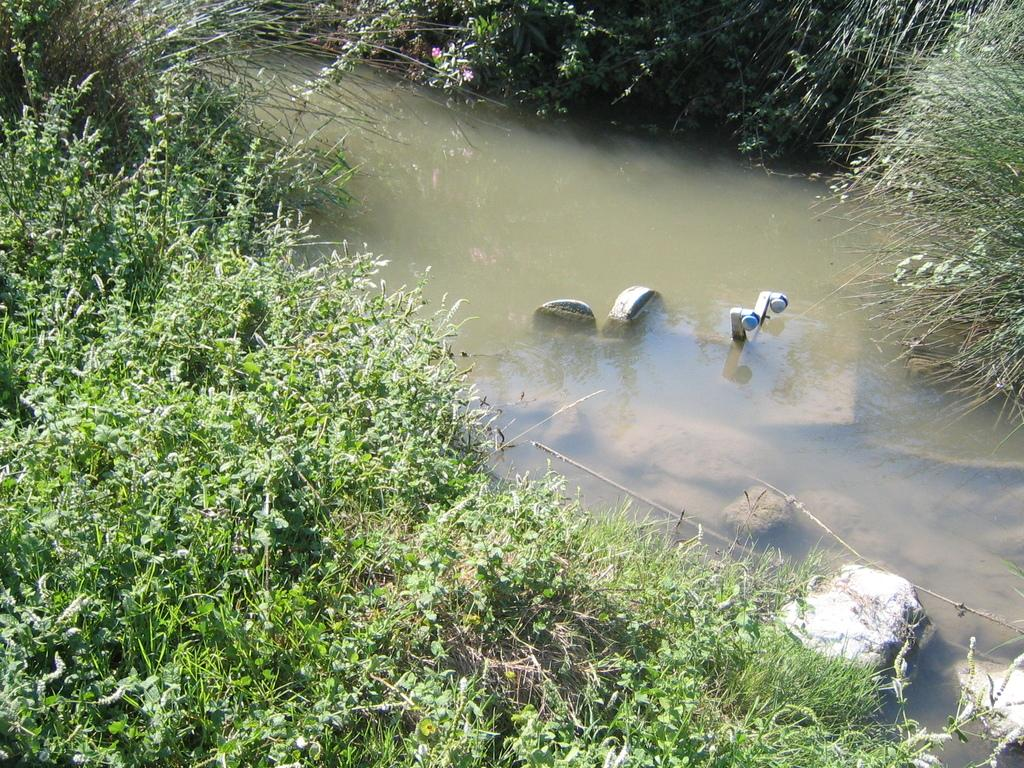What is the primary element visible in the image? There is water in the image. What other natural elements can be seen in the image? There are rocks, grass, and plants in the image. Where is the cloth hanging in the image? There is no cloth present in the image. Can you see any cobwebs in the image? There are no cobwebs visible in the image. 